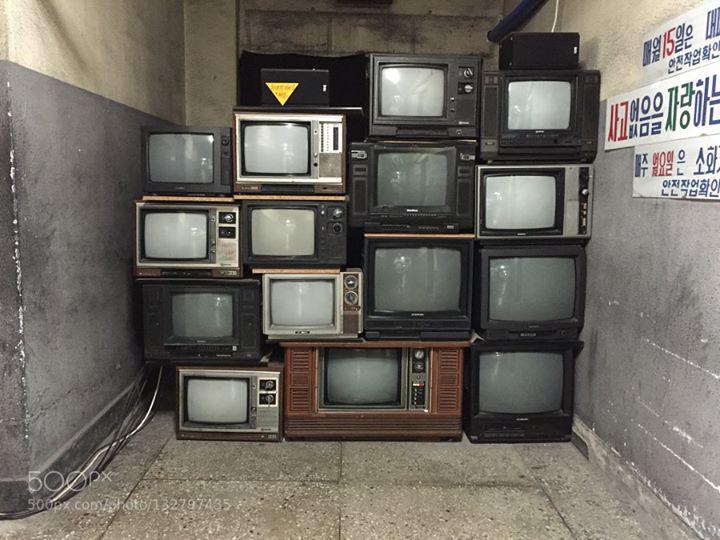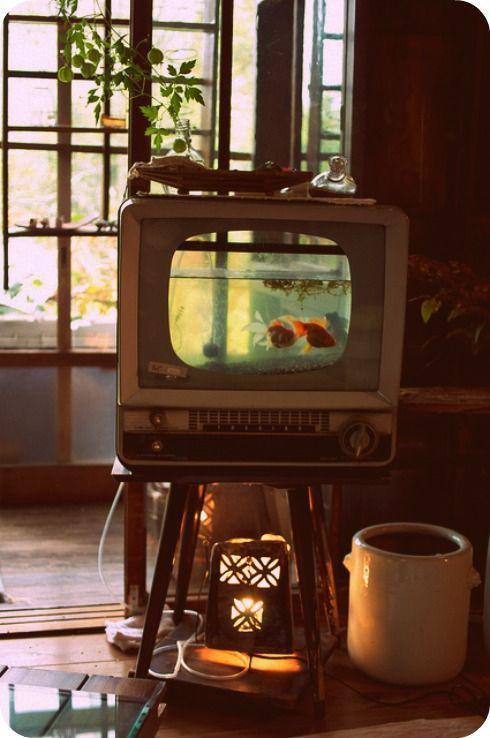The first image is the image on the left, the second image is the image on the right. Examine the images to the left and right. Is the description "The right image contains exactly five old fashioned television sets." accurate? Answer yes or no. No. The first image is the image on the left, the second image is the image on the right. Evaluate the accuracy of this statement regarding the images: "A stack of old-fashioned TVs includes at least one with a rainbow test pattern and two knobs in a vertical row alongside the screen.". Is it true? Answer yes or no. No. 